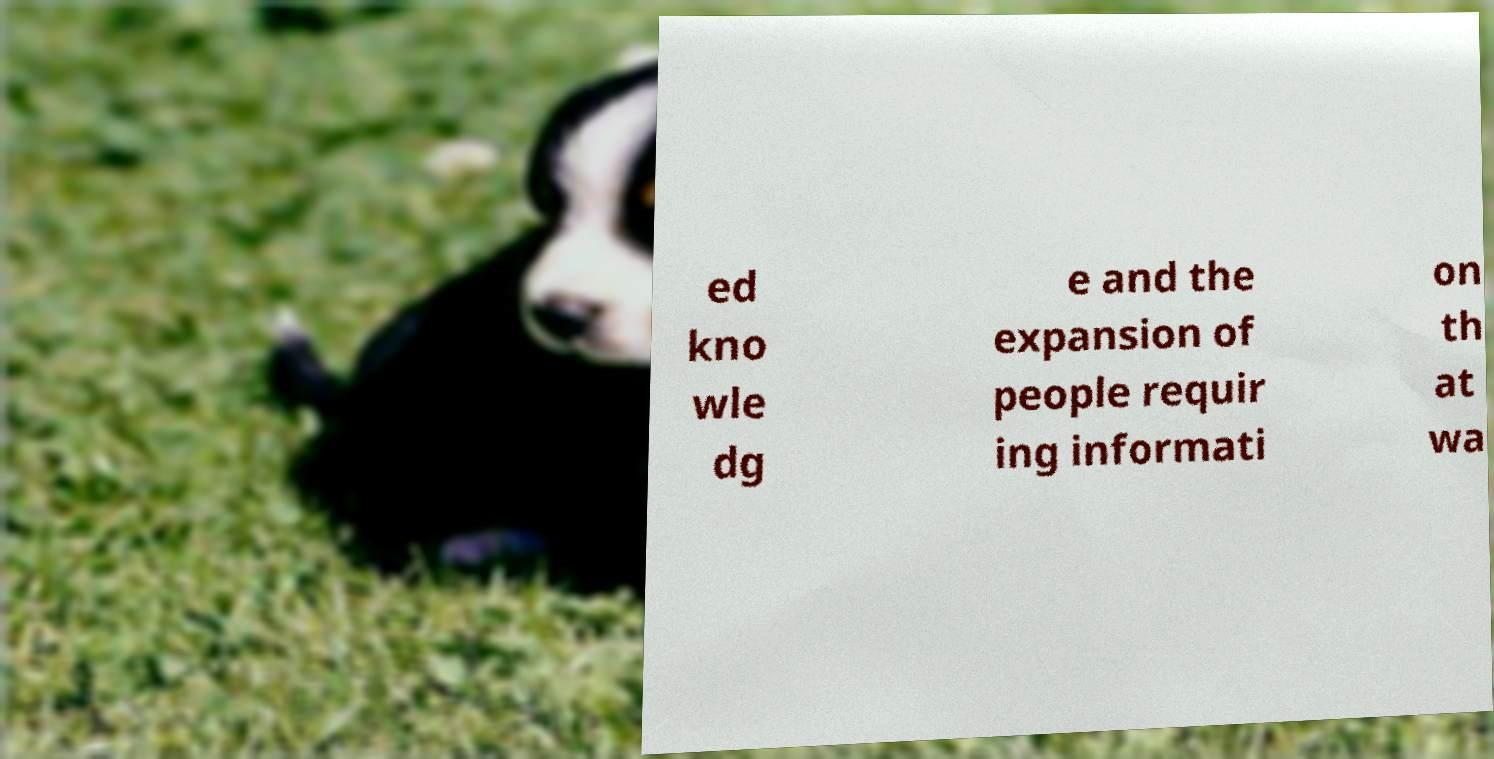There's text embedded in this image that I need extracted. Can you transcribe it verbatim? ed kno wle dg e and the expansion of people requir ing informati on th at wa 